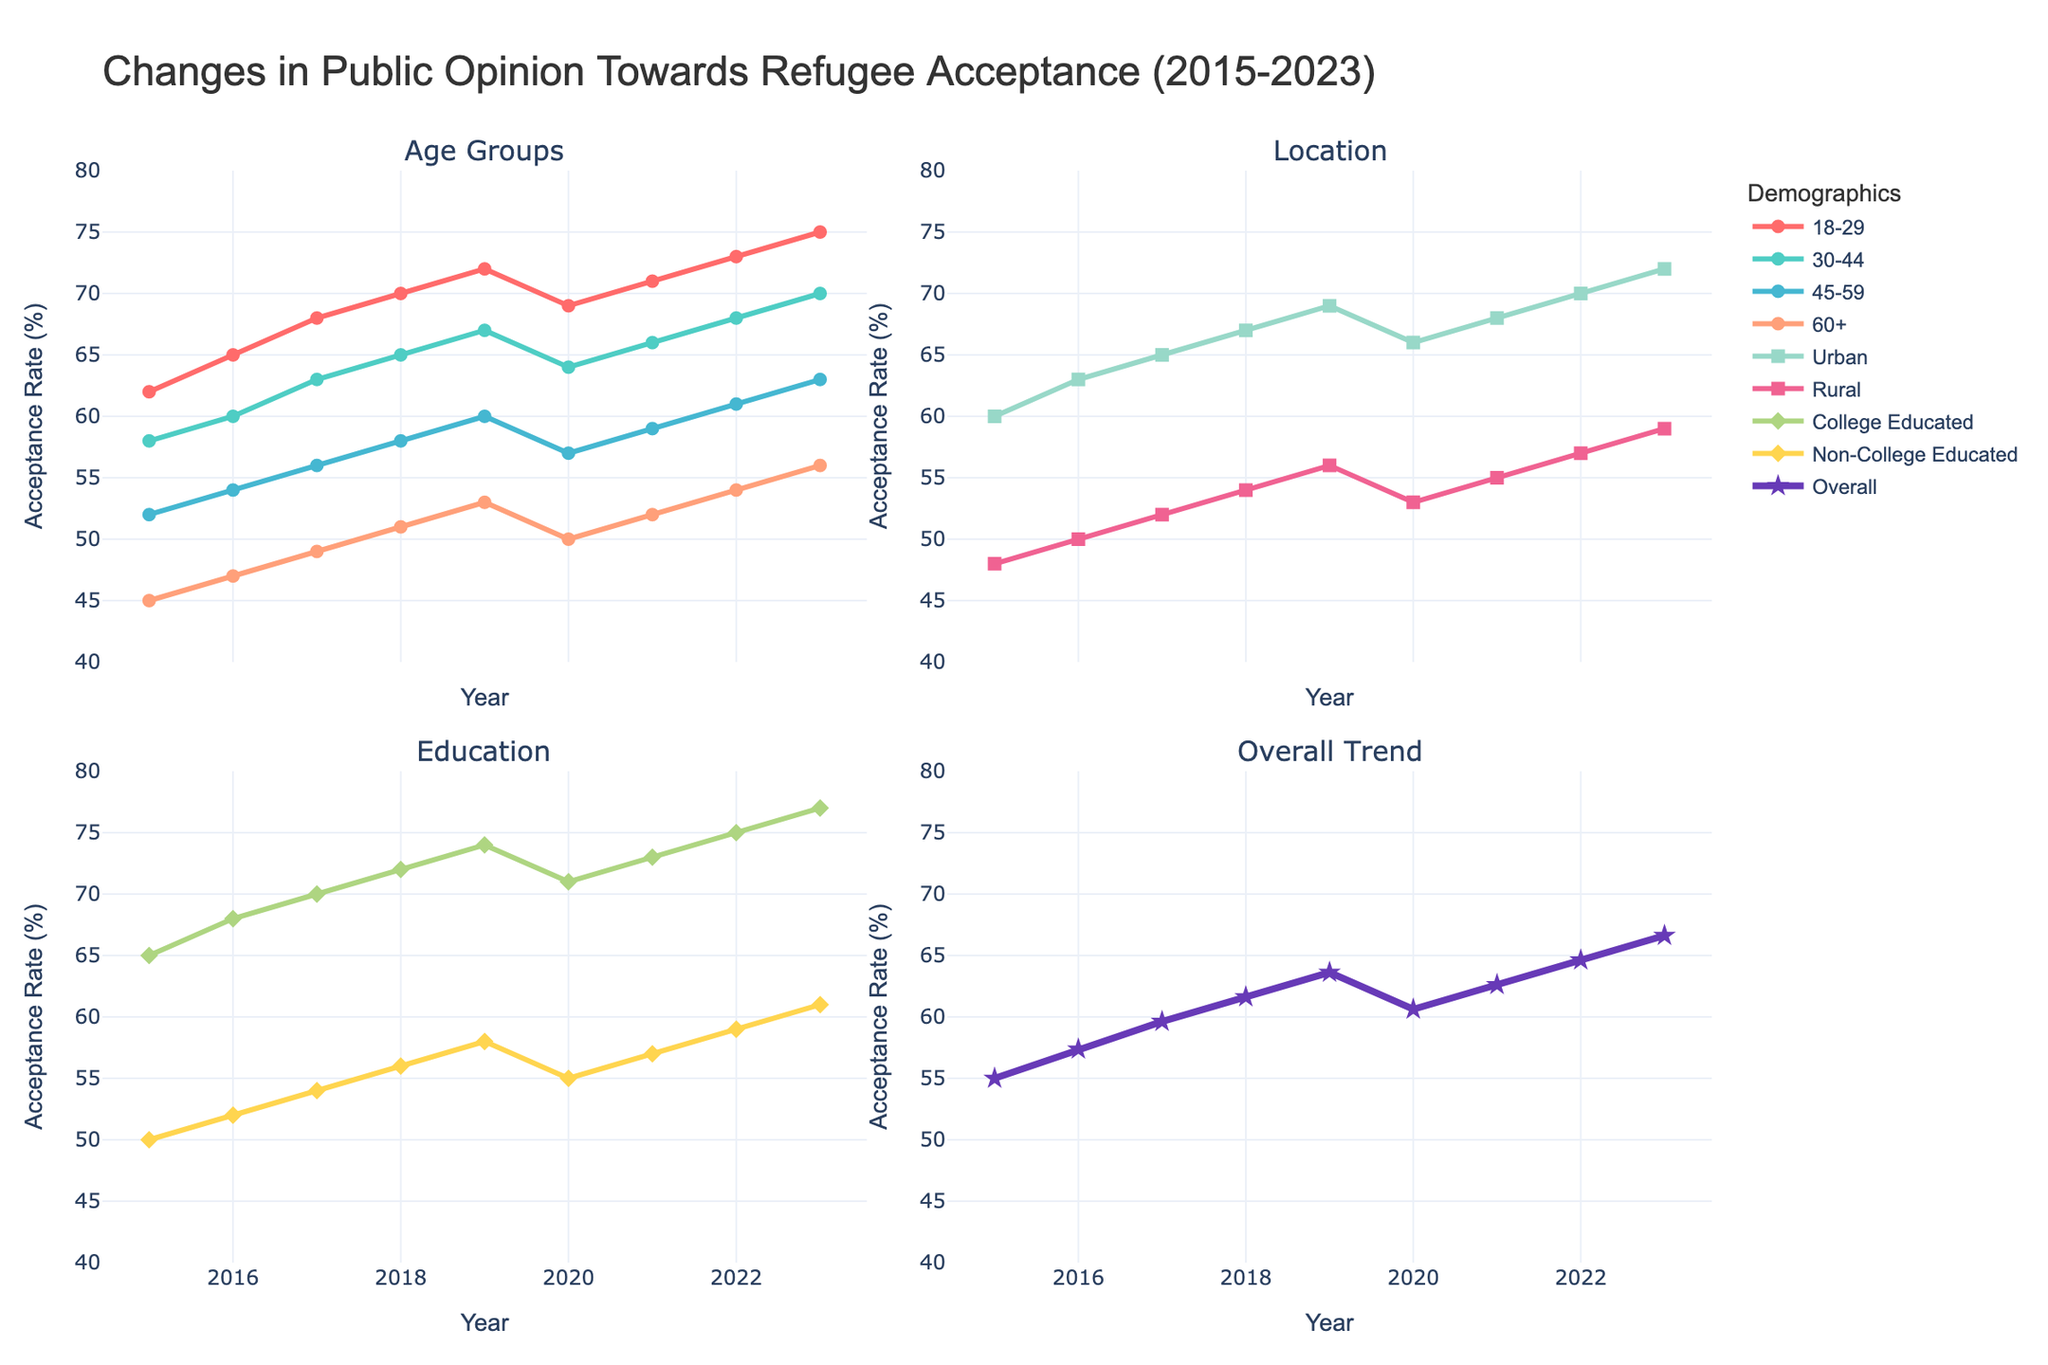What was the acceptance rate for the group aged 18-29 in 2017? Check the "18-29" line at the year mark 2017 in the "Age Groups" subplot, which shows 68%.
Answer: 68% Which demographic group had the least acceptance rate in 2023? Compare each line's point in 2023 across all subplots (Age Groups, Location, Education). The "60+" group has the lowest at 56%.
Answer: 60+ How did the acceptance rate among the rural population change from 2015 to 2020? Identify the starting and ending points of the "Rural" line in the "Location" subplot. It was 48% in 2015 and 53% in 2020. So, the change is 53% - 48% = 5%.
Answer: 5% Which group saw the highest overall increase in acceptance rate from 2015 to 2023? Calculate the difference between 2015 and 2023 for each group and compare them. The "60+" group increased from 45% to 56%, the highest absolute increase.
Answer: 60+ What's the average acceptance rate across all groups in the year 2020? Find the value of each group for 2020 and then calculate the average: (69+64+57+50+66+53+71+55)/8 = 60.625%.
Answer: 60.625% Which demographic had a higher acceptance rate in 2019: Urban or College Educated? Compare the 2019 points on the "Urban" and "College Educated" lines in their respective subplots. Urban is 69% and College Educated is 74%.
Answer: College Educated By how many percentage points did the acceptance rate for 30-44 change from 2018 to 2019? Look at the 30-44 group's points for 2018 and 2019, which are 65% and 67% respectively. The change is 67% - 65% = 2%.
Answer: 2% Which year did the non-college educated group's acceptance rate first go above 55%? Follow the "Non-College Educated" line and find the year point where it first crosses 55%. This occurs in 2021.
Answer: 2021 Describe the trend for acceptance rates in the "18-29" group from 2015 to 2023. The "18-29" line in the "Age Groups" subplot shows a consistent upward trend from 62% in 2015 to 75% in 2023.
Answer: Upward trend Is there any group that shows a declining trend from 2019 to 2020? Check each group's line between 2019 and 2020. The "18-29", "30-44", "45-59", "60+", "Urban", and "Rural" groups all show dips in this period.
Answer: Yes (multiple groups: 18-29, 30-44, 45-59, 60+, Urban, Rural) 